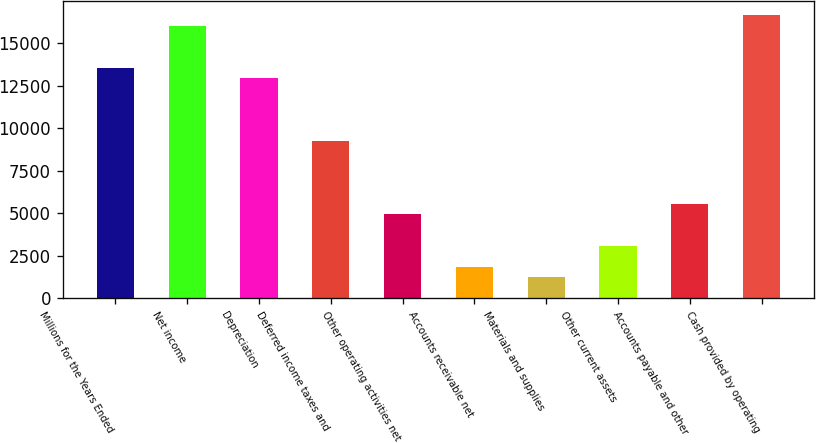Convert chart. <chart><loc_0><loc_0><loc_500><loc_500><bar_chart><fcel>Millions for the Years Ended<fcel>Net income<fcel>Depreciation<fcel>Deferred income taxes and<fcel>Other operating activities net<fcel>Accounts receivable net<fcel>Materials and supplies<fcel>Other current assets<fcel>Accounts payable and other<fcel>Cash provided by operating<nl><fcel>13553<fcel>16017<fcel>12937<fcel>9241<fcel>4929<fcel>1849<fcel>1233<fcel>3081<fcel>5545<fcel>16633<nl></chart> 